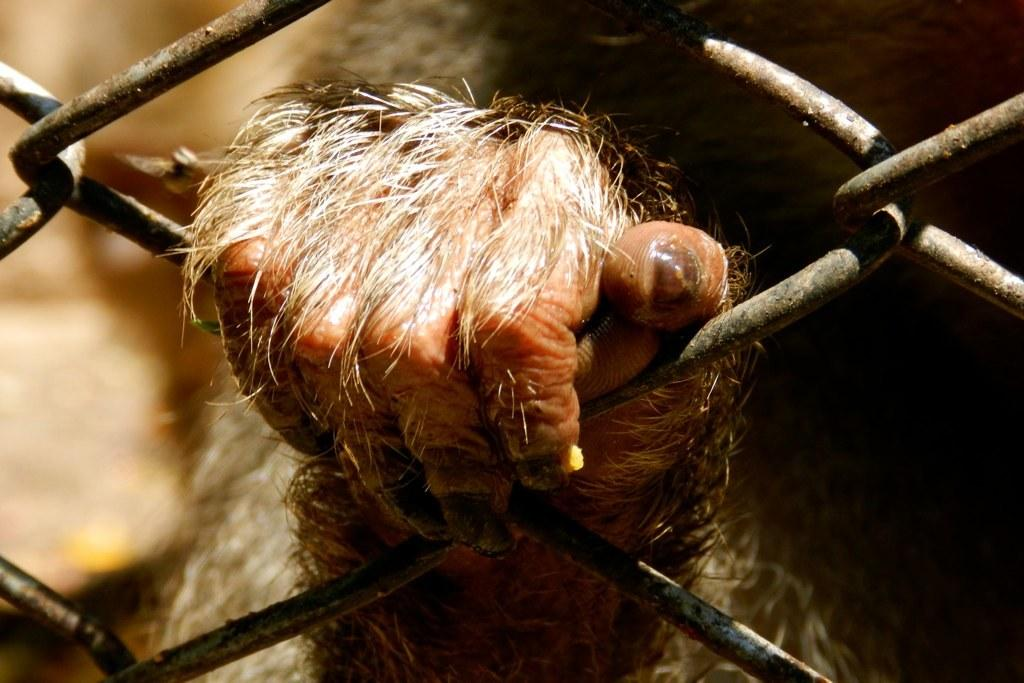What is the main subject of the image? The main subject of the image is the hand of an animal. Can you describe the background of the image? The background of the image is blurry. What can be seen in the foreground of the image? There are grills visible in the front of the image. What type of blade is being used by the scarecrow in the image? There is no scarecrow or blade present in the image. How is the brother interacting with the animal's hand in the image? There is no brother present in the image, and therefore no interaction with the animal's hand can be observed. 